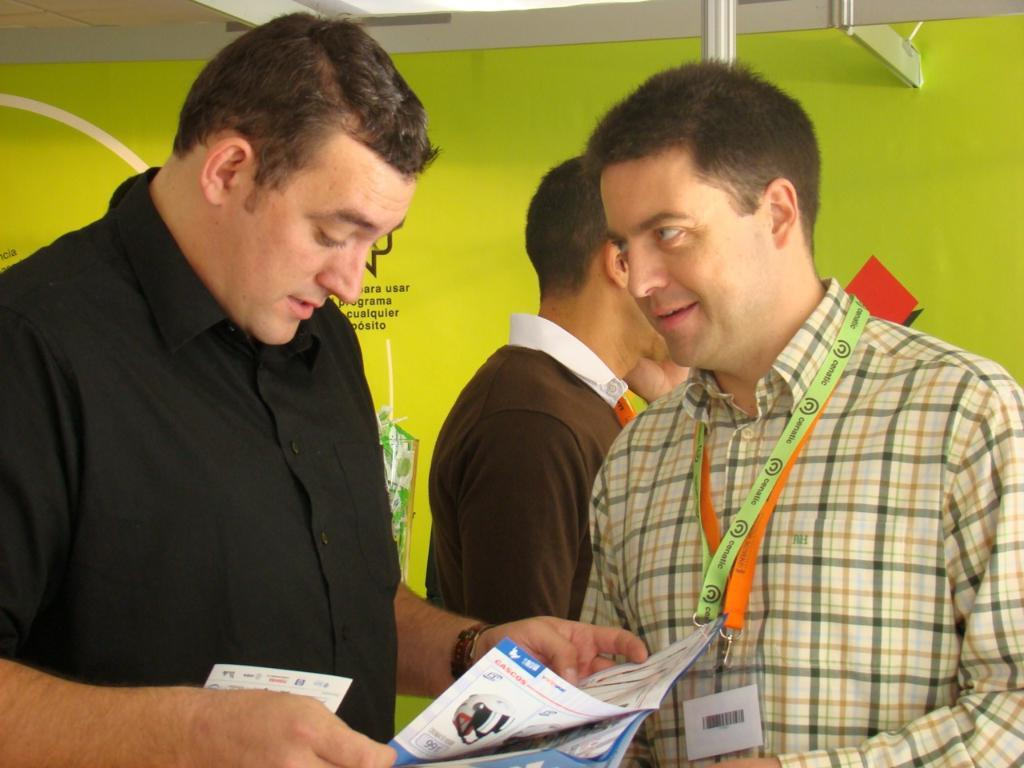How many people are in the image? There are three persons in the image. What is one person holding in the image? One person is holding a book. Can you describe the background of the image? There is a board in the background of the image. What type of crime is being committed in the image? There is no indication of any crime being committed in the image. What color is the marble in the image? There is no marble present in the image. 